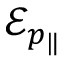<formula> <loc_0><loc_0><loc_500><loc_500>\mathcal { E } _ { p _ { \| } }</formula> 